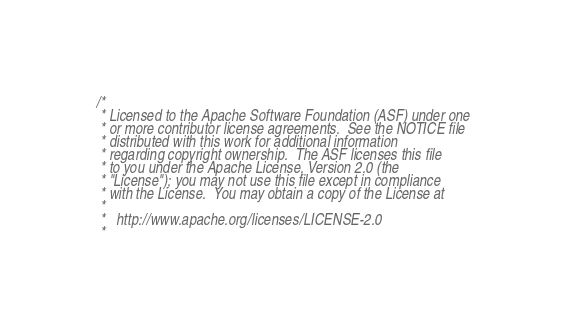Convert code to text. <code><loc_0><loc_0><loc_500><loc_500><_Scala_>/*
 * Licensed to the Apache Software Foundation (ASF) under one
 * or more contributor license agreements.  See the NOTICE file
 * distributed with this work for additional information
 * regarding copyright ownership.  The ASF licenses this file
 * to you under the Apache License, Version 2.0 (the
 * "License"); you may not use this file except in compliance
 * with the License.  You may obtain a copy of the License at
 *
 *   http://www.apache.org/licenses/LICENSE-2.0
 *</code> 